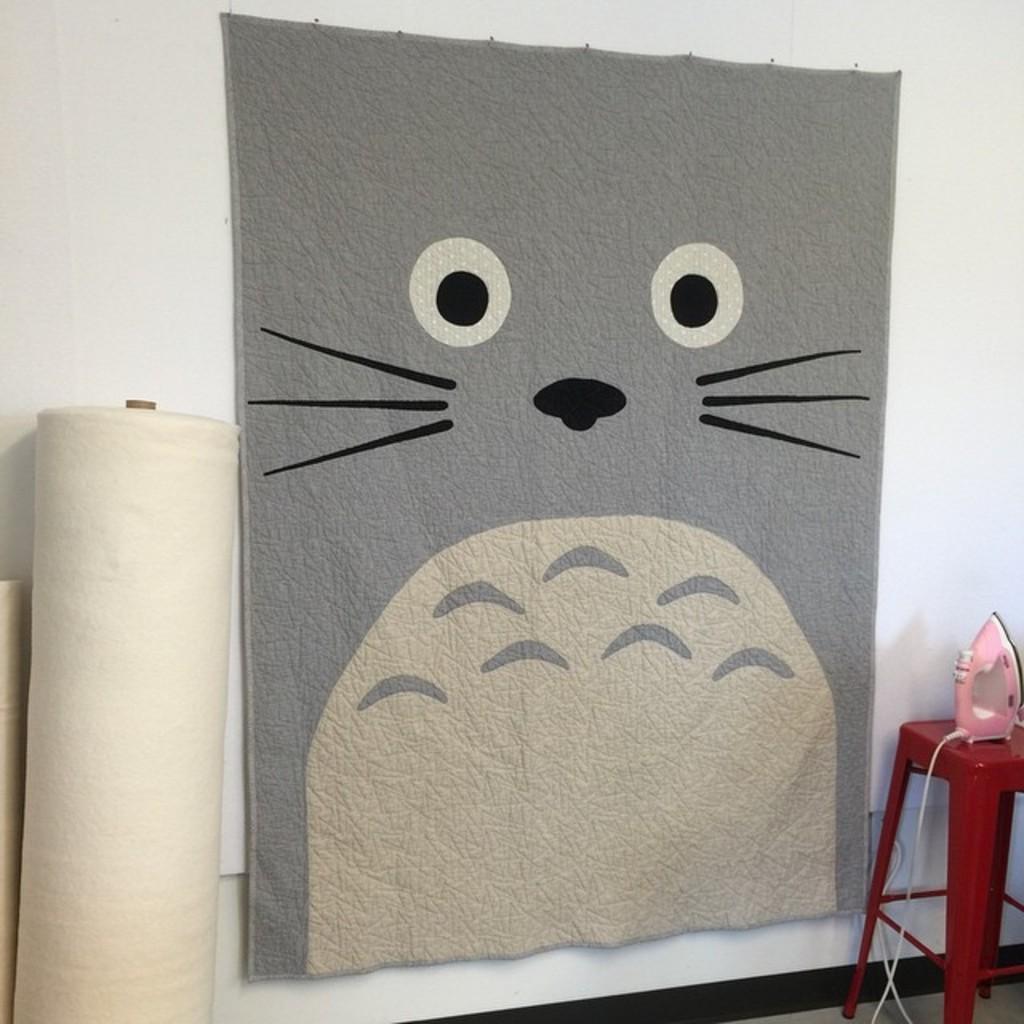Can you describe this image briefly? In this picture we can see an iron box on the table. There are white objects visible on the left side. We can see a cloth on a white surface. 